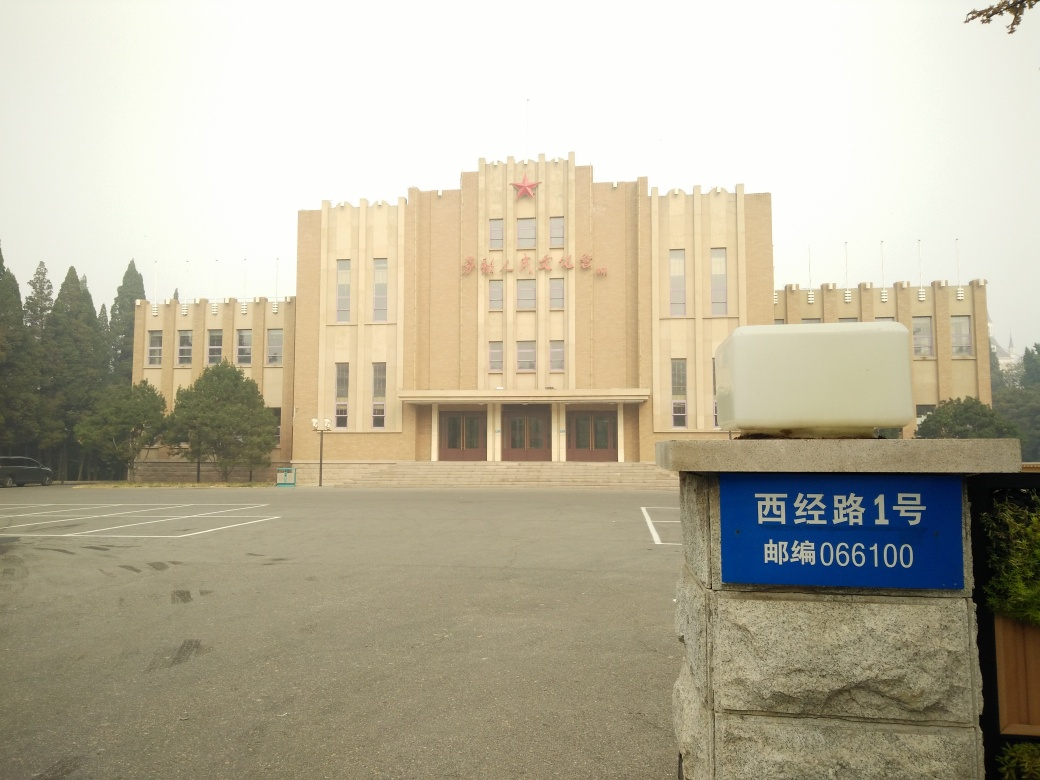What is the condition of the ground's texture details?
A. enhanced
B. lost most
C. intact Upon examining the ground's surface in the image, it becomes apparent that the texture details of the pavement are mostly intact, although some spots are either worn or have mild distortions likely due to use and weathering. Therefore, option C would be the most accurate answer. 